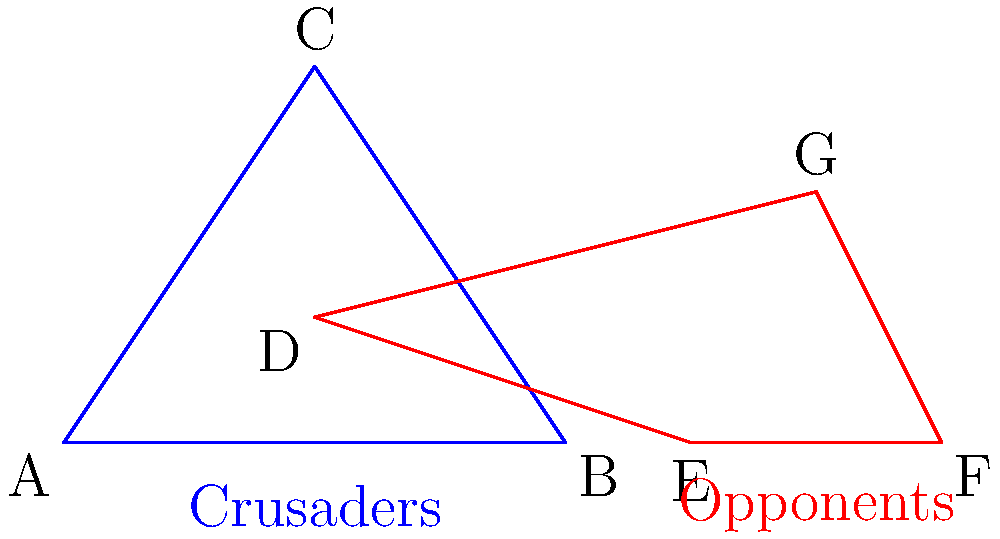Analyze the battle formations depicted in the diagram. How many pairs of congruent triangles can be identified between the Crusaders' formation (blue) and their opponents' formation (red)? Explain the religious significance of this congruence in the context of the Crusades. To answer this question, we need to follow these steps:

1. Identify the triangles in each formation:
   - Crusaders' formation: Triangle ABC
   - Opponents' formation: Triangles DEF, DFG, and DEG

2. Compare the triangles for congruence:
   a) Triangle ABC vs. Triangle DEF:
      - AB ≅ DE (base of the formations)
      - AC ≅ DF (sides of the formations)
      - BC ≅ EF (sides of the formations)
      These triangles are congruent by the Side-Side-Side (SSS) congruence theorem.

   b) Triangle ABC vs. Triangle DFG:
      - These triangles are not congruent as their shapes differ significantly.

   c) Triangle ABC vs. Triangle DEG:
      - These triangles are not congruent as their shapes differ significantly.

3. Count the number of congruent triangle pairs: 1 pair (ABC ≅ DEF)

4. Religious significance:
   The congruence between the Crusaders' and their opponents' formations can be interpreted as a symbol of the shared humanity and equality before God of both sides, despite their religious differences. This geometric similarity might be seen as a divine reminder that both Christians and Muslims are created in God's image, challenging the notion of religious superiority that often fueled the Crusades.

   Furthermore, the single point of congruence amidst differences could represent the common Abrahamic roots of Christianity and Islam, emphasizing the potential for dialogue and understanding between the two faiths. This geometric insight invites theologians to reflect on the shared spiritual heritage and the possibility of reconciliation, even in the context of historical conflict.
Answer: 1 pair; symbolizes shared humanity and Abrahamic roots 